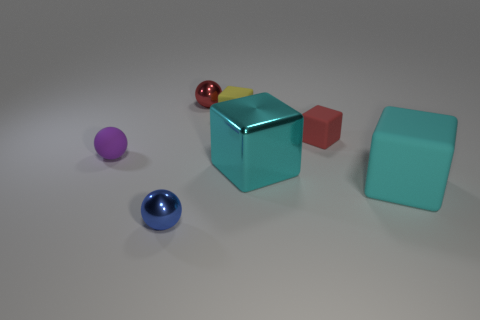Is the number of tiny yellow blocks in front of the yellow cube less than the number of small matte things in front of the red block?
Your answer should be compact. Yes. Does the big cube that is behind the large rubber thing have the same material as the thing in front of the large cyan matte block?
Your answer should be very brief. Yes. The large cyan shiny object has what shape?
Offer a terse response. Cube. Are there more tiny red things that are in front of the metal cube than purple rubber balls that are in front of the small yellow object?
Your answer should be very brief. No. There is a red object that is in front of the red ball; is it the same shape as the small matte thing left of the red metallic thing?
Keep it short and to the point. No. What number of other things are the same size as the purple rubber ball?
Provide a short and direct response. 4. How big is the yellow matte cube?
Provide a succinct answer. Small. Are the tiny red thing that is to the right of the small red shiny ball and the tiny yellow cube made of the same material?
Offer a terse response. Yes. What color is the tiny rubber thing that is the same shape as the red shiny thing?
Provide a short and direct response. Purple. Is the color of the shiny ball that is behind the tiny blue metal thing the same as the big metallic thing?
Make the answer very short. No. 